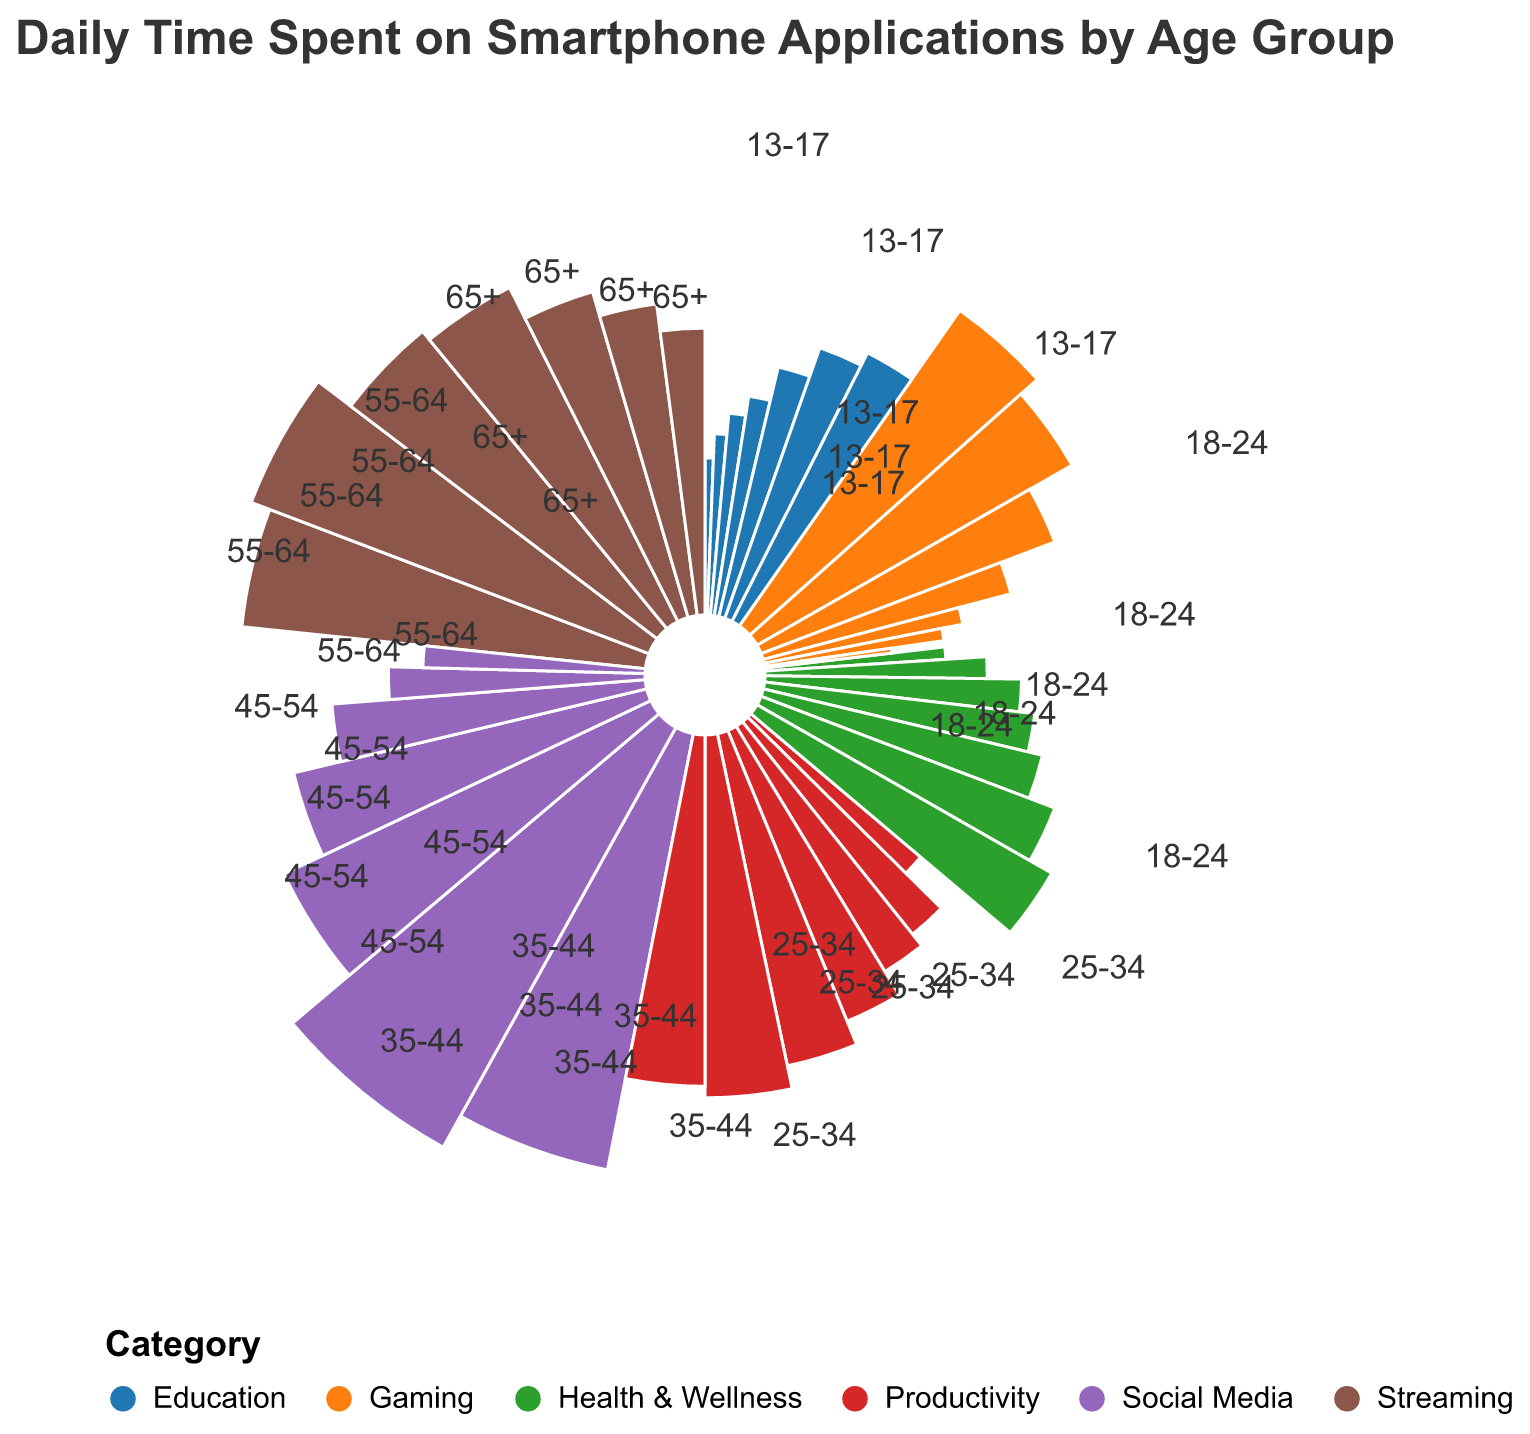Which age group spends the most daily time on social media? By observing the figure, we identify the sector representing social media and compare the values for each age group. The largest value for social media is 140 minutes in the 18-24 age group.
Answer: 18-24 Which category comprises the highest daily time for the 13-17 age group? By examining the figure, we focus on the sectors for the 13-17 age group. The sector with the largest value is social media at 120 minutes.
Answer: Social Media How much more time does the 25-34 age group spend on productivity compared to gaming? From the chart, note the values for productivity (50 minutes) and gaming (60 minutes) for the 25-34 age group. The difference is 50 - 60 = -10 minutes.
Answer: 10 minutes less Which age group spends the most time on health & wellness? Observe the chart to find the health & wellness sector and compare all age groups. The 65+ age group spends the most time with 70 minutes.
Answer: 65+ What is the total daily time spent on smartphone applications for the 55-64 age group? For the 55-64 age group, sum the times for all categories: 40 (Social Media) + 20 (Gaming) + 80 (Productivity) + 60 (Health & Wellness) + 50 (Education) + 60 (Streaming) = 310 minutes.
Answer: 310 minutes Which age group spends least time on gaming? By checking the gaming sector values for each age group, the smallest value is 10 minutes for the 65+ age group.
Answer: 65+ Compare the time spent on streaming by 18-24 and 35-44 age groups. Which one is greater? The 18-24 age group spends 110 minutes on streaming, while the 35-44 age group spends 85 minutes. 110 is greater than 85.
Answer: 18-24 What is the average daily time spent on education by the age groups 45-54 and 65+? The education times are 40 minutes (45-54) and 55 minutes (65+). Their sum is 40 + 55 = 95 minutes, and the average is 95 / 2 = 47.5 minutes.
Answer: 47.5 minutes 